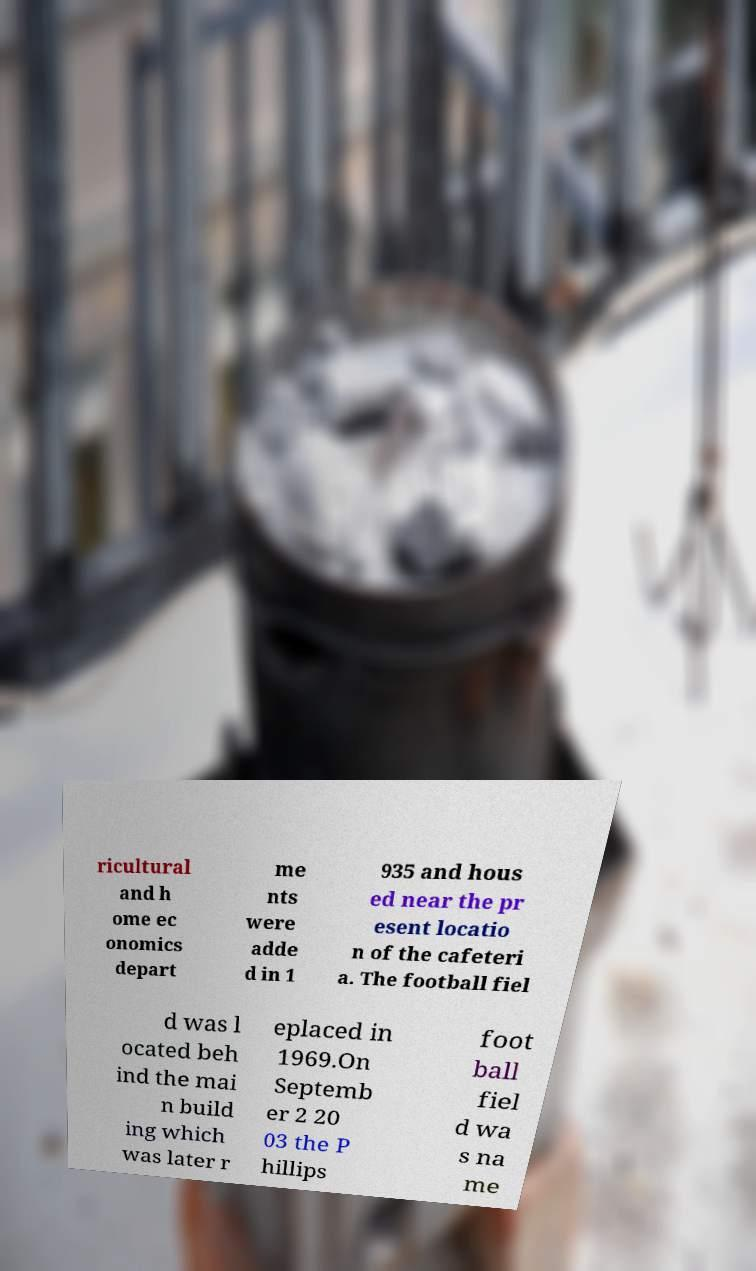Can you accurately transcribe the text from the provided image for me? ricultural and h ome ec onomics depart me nts were adde d in 1 935 and hous ed near the pr esent locatio n of the cafeteri a. The football fiel d was l ocated beh ind the mai n build ing which was later r eplaced in 1969.On Septemb er 2 20 03 the P hillips foot ball fiel d wa s na me 